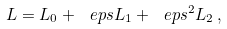<formula> <loc_0><loc_0><loc_500><loc_500>\L L = \L L _ { 0 } + \ e p s \L L _ { 1 } + \ e p s ^ { 2 } \L L _ { 2 } \, ,</formula> 